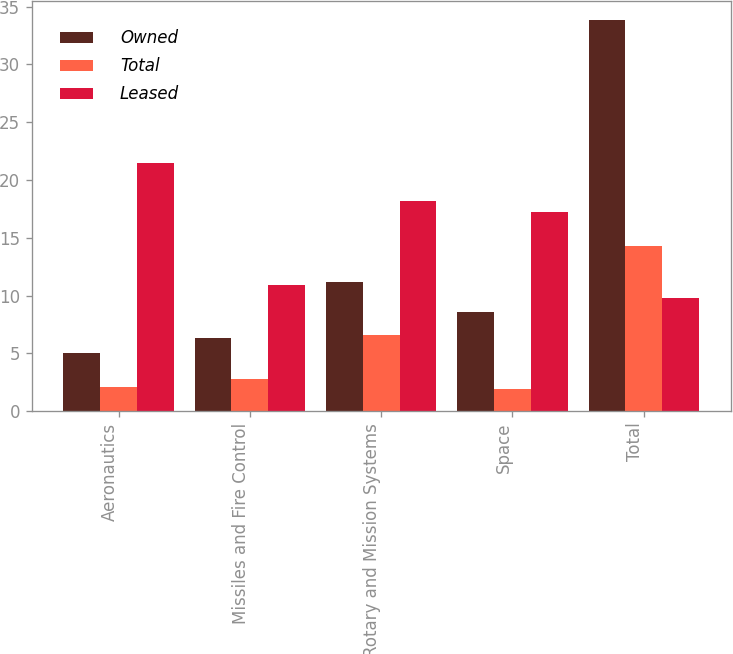Convert chart. <chart><loc_0><loc_0><loc_500><loc_500><stacked_bar_chart><ecel><fcel>Aeronautics<fcel>Missiles and Fire Control<fcel>Rotary and Mission Systems<fcel>Space<fcel>Total<nl><fcel>Owned<fcel>5<fcel>6.3<fcel>11.2<fcel>8.6<fcel>33.8<nl><fcel>Total<fcel>2.1<fcel>2.8<fcel>6.6<fcel>1.9<fcel>14.3<nl><fcel>Leased<fcel>21.5<fcel>10.9<fcel>18.2<fcel>17.2<fcel>9.75<nl></chart> 